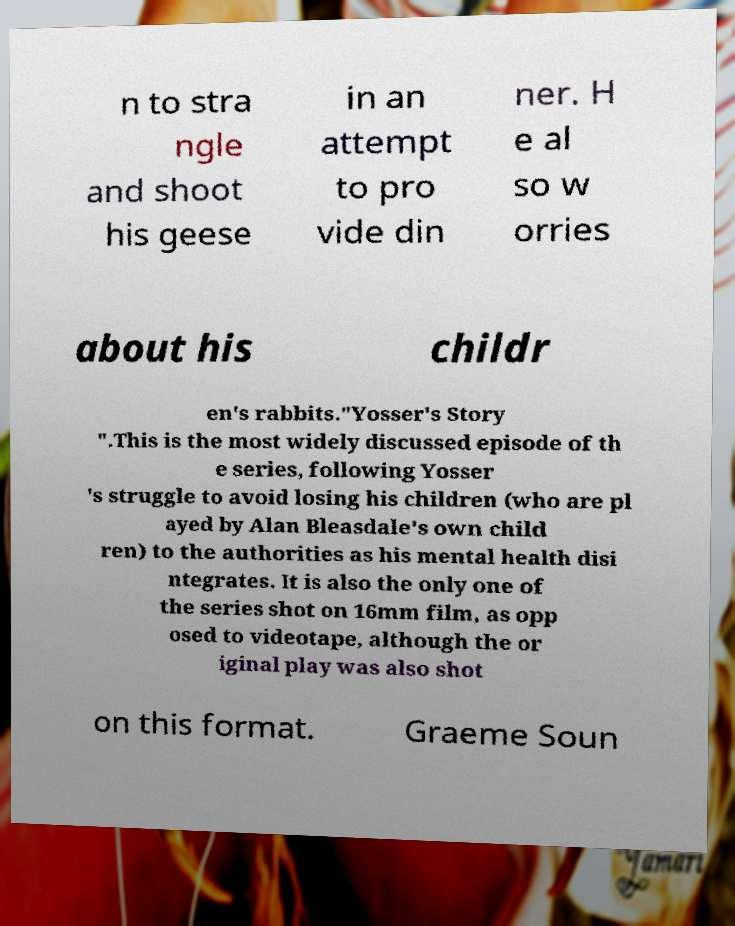Please identify and transcribe the text found in this image. n to stra ngle and shoot his geese in an attempt to pro vide din ner. H e al so w orries about his childr en's rabbits."Yosser's Story ".This is the most widely discussed episode of th e series, following Yosser 's struggle to avoid losing his children (who are pl ayed by Alan Bleasdale's own child ren) to the authorities as his mental health disi ntegrates. It is also the only one of the series shot on 16mm film, as opp osed to videotape, although the or iginal play was also shot on this format. Graeme Soun 